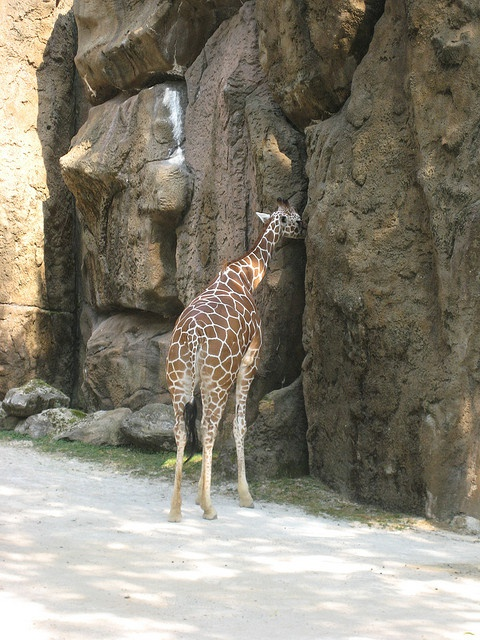Describe the objects in this image and their specific colors. I can see a giraffe in tan, gray, darkgray, and lightgray tones in this image. 